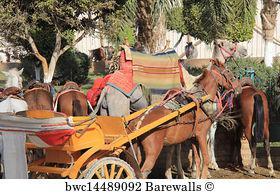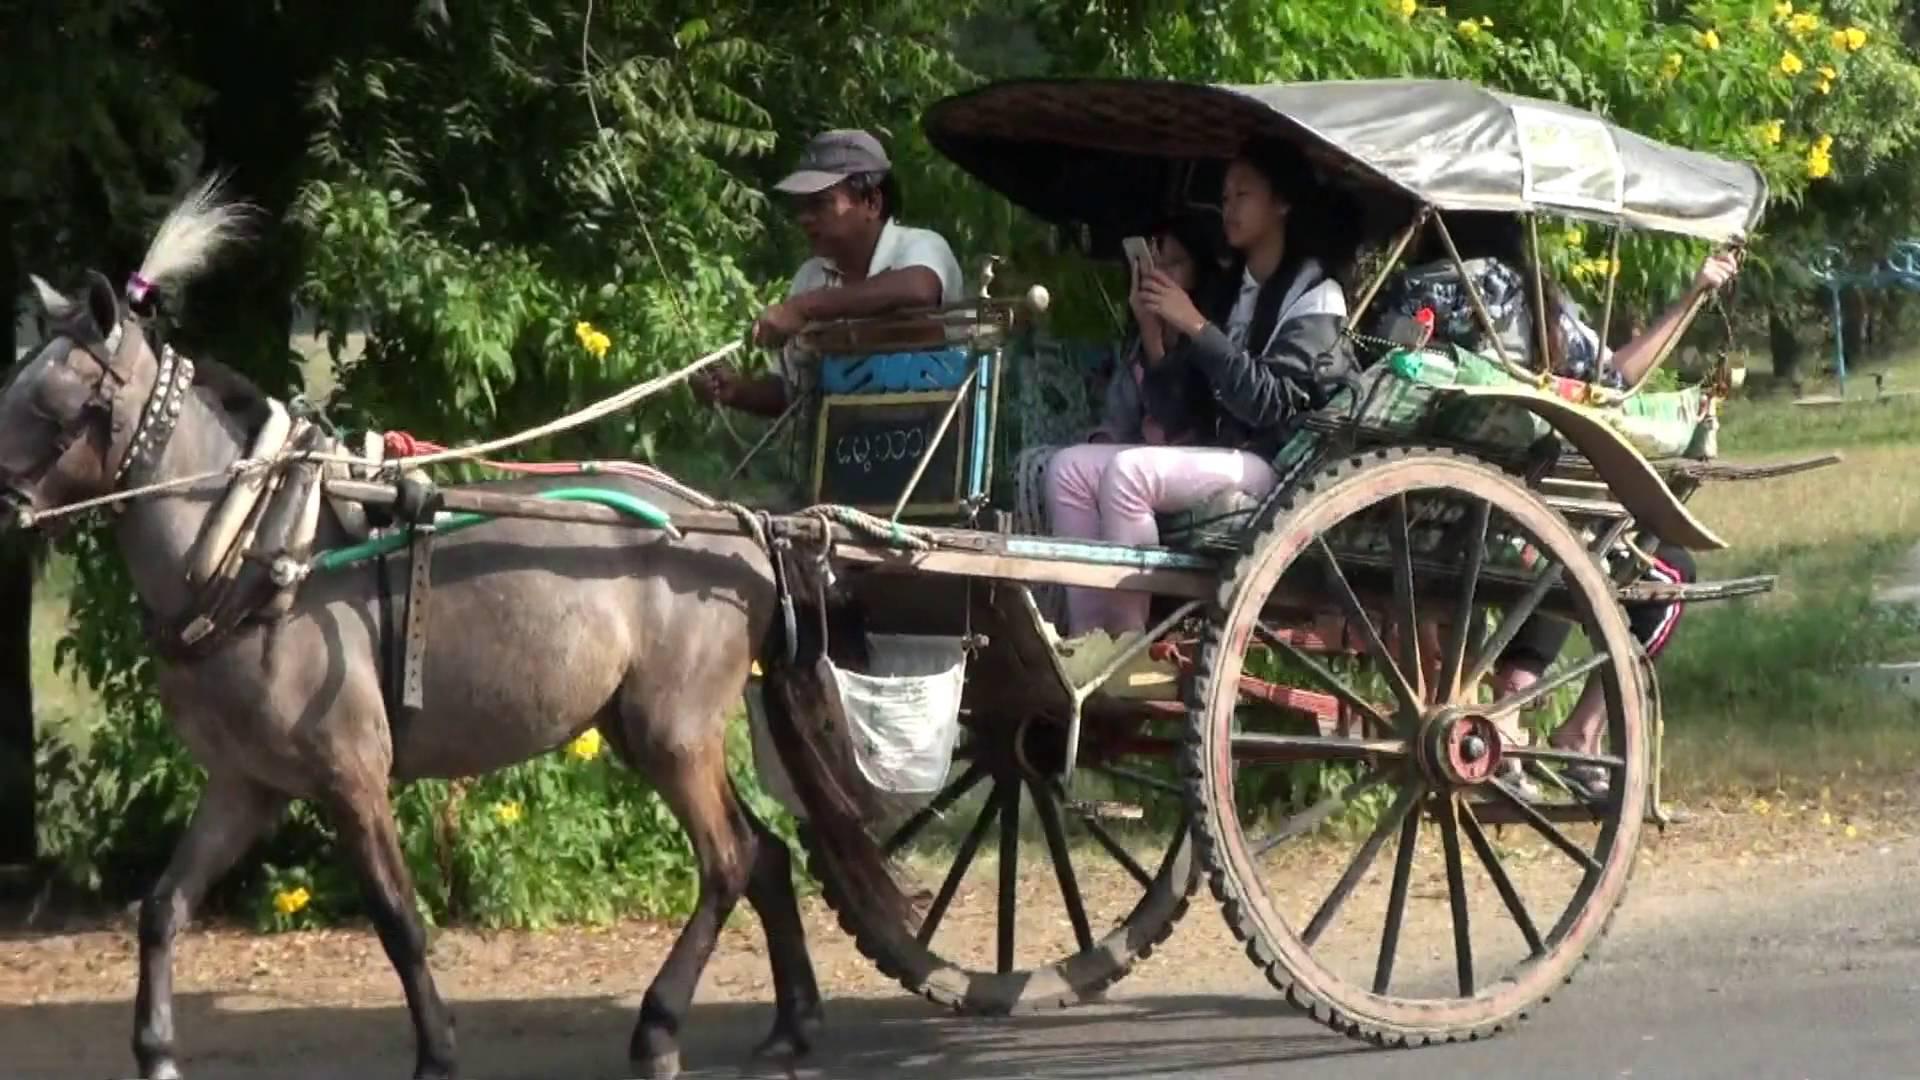The first image is the image on the left, the second image is the image on the right. Analyze the images presented: Is the assertion "The right image shows a passenger in a two-wheeled horse-drawn cart, and the left image shows a passenger-less two-wheeled cart hitched to a horse." valid? Answer yes or no. Yes. 